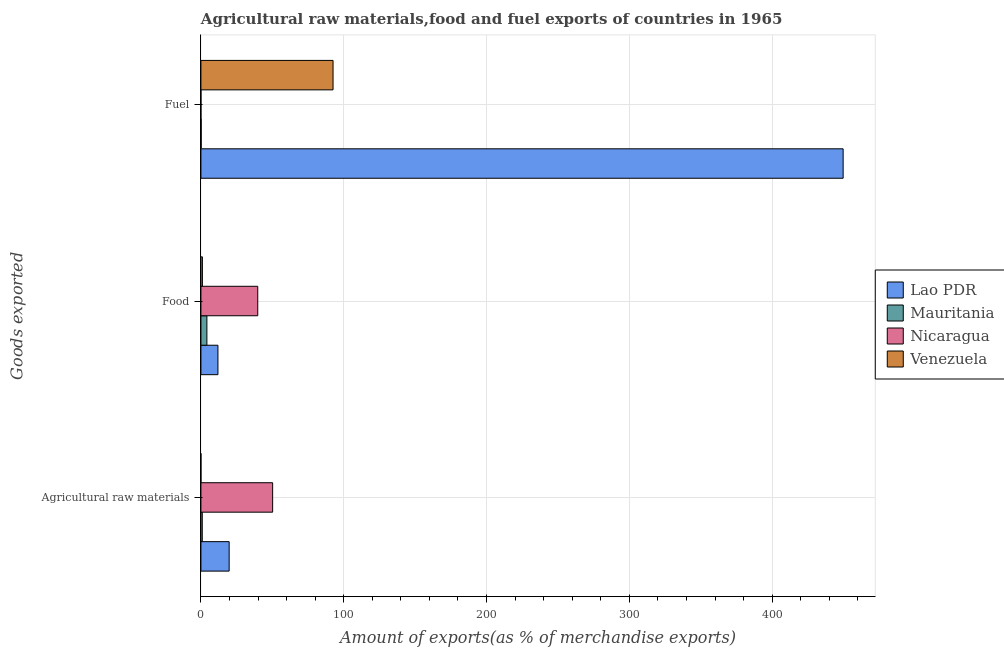How many different coloured bars are there?
Your answer should be very brief. 4. How many groups of bars are there?
Give a very brief answer. 3. Are the number of bars per tick equal to the number of legend labels?
Ensure brevity in your answer.  Yes. Are the number of bars on each tick of the Y-axis equal?
Ensure brevity in your answer.  Yes. How many bars are there on the 2nd tick from the top?
Ensure brevity in your answer.  4. What is the label of the 3rd group of bars from the top?
Provide a succinct answer. Agricultural raw materials. What is the percentage of raw materials exports in Venezuela?
Provide a succinct answer. 0.02. Across all countries, what is the maximum percentage of raw materials exports?
Make the answer very short. 50.22. Across all countries, what is the minimum percentage of food exports?
Offer a terse response. 1.05. In which country was the percentage of food exports maximum?
Provide a succinct answer. Nicaragua. In which country was the percentage of fuel exports minimum?
Provide a succinct answer. Nicaragua. What is the total percentage of fuel exports in the graph?
Give a very brief answer. 542.43. What is the difference between the percentage of raw materials exports in Mauritania and that in Lao PDR?
Make the answer very short. -18.83. What is the difference between the percentage of raw materials exports in Venezuela and the percentage of fuel exports in Mauritania?
Offer a very short reply. -0.17. What is the average percentage of fuel exports per country?
Provide a succinct answer. 135.61. What is the difference between the percentage of raw materials exports and percentage of food exports in Lao PDR?
Ensure brevity in your answer.  7.85. In how many countries, is the percentage of food exports greater than 60 %?
Ensure brevity in your answer.  0. What is the ratio of the percentage of raw materials exports in Venezuela to that in Mauritania?
Offer a very short reply. 0.02. Is the difference between the percentage of fuel exports in Venezuela and Lao PDR greater than the difference between the percentage of food exports in Venezuela and Lao PDR?
Your answer should be compact. No. What is the difference between the highest and the second highest percentage of food exports?
Offer a terse response. 27.88. What is the difference between the highest and the lowest percentage of fuel exports?
Make the answer very short. 449.71. In how many countries, is the percentage of raw materials exports greater than the average percentage of raw materials exports taken over all countries?
Your answer should be compact. 2. Is the sum of the percentage of food exports in Nicaragua and Mauritania greater than the maximum percentage of fuel exports across all countries?
Provide a succinct answer. No. What does the 4th bar from the top in Fuel represents?
Keep it short and to the point. Lao PDR. What does the 4th bar from the bottom in Food represents?
Make the answer very short. Venezuela. How many bars are there?
Keep it short and to the point. 12. Are all the bars in the graph horizontal?
Offer a terse response. Yes. How many countries are there in the graph?
Provide a short and direct response. 4. What is the difference between two consecutive major ticks on the X-axis?
Ensure brevity in your answer.  100. Where does the legend appear in the graph?
Your response must be concise. Center right. How many legend labels are there?
Offer a terse response. 4. What is the title of the graph?
Keep it short and to the point. Agricultural raw materials,food and fuel exports of countries in 1965. What is the label or title of the X-axis?
Ensure brevity in your answer.  Amount of exports(as % of merchandise exports). What is the label or title of the Y-axis?
Your answer should be compact. Goods exported. What is the Amount of exports(as % of merchandise exports) of Lao PDR in Agricultural raw materials?
Provide a short and direct response. 19.77. What is the Amount of exports(as % of merchandise exports) in Mauritania in Agricultural raw materials?
Ensure brevity in your answer.  0.94. What is the Amount of exports(as % of merchandise exports) of Nicaragua in Agricultural raw materials?
Offer a terse response. 50.22. What is the Amount of exports(as % of merchandise exports) in Venezuela in Agricultural raw materials?
Your answer should be very brief. 0.02. What is the Amount of exports(as % of merchandise exports) of Lao PDR in Food?
Provide a short and direct response. 11.92. What is the Amount of exports(as % of merchandise exports) in Mauritania in Food?
Keep it short and to the point. 4.18. What is the Amount of exports(as % of merchandise exports) of Nicaragua in Food?
Your answer should be compact. 39.8. What is the Amount of exports(as % of merchandise exports) of Venezuela in Food?
Make the answer very short. 1.05. What is the Amount of exports(as % of merchandise exports) of Lao PDR in Fuel?
Offer a very short reply. 449.72. What is the Amount of exports(as % of merchandise exports) in Mauritania in Fuel?
Give a very brief answer. 0.19. What is the Amount of exports(as % of merchandise exports) of Nicaragua in Fuel?
Provide a short and direct response. 0.01. What is the Amount of exports(as % of merchandise exports) in Venezuela in Fuel?
Your response must be concise. 92.52. Across all Goods exported, what is the maximum Amount of exports(as % of merchandise exports) in Lao PDR?
Keep it short and to the point. 449.72. Across all Goods exported, what is the maximum Amount of exports(as % of merchandise exports) of Mauritania?
Offer a terse response. 4.18. Across all Goods exported, what is the maximum Amount of exports(as % of merchandise exports) in Nicaragua?
Your response must be concise. 50.22. Across all Goods exported, what is the maximum Amount of exports(as % of merchandise exports) in Venezuela?
Provide a short and direct response. 92.52. Across all Goods exported, what is the minimum Amount of exports(as % of merchandise exports) of Lao PDR?
Ensure brevity in your answer.  11.92. Across all Goods exported, what is the minimum Amount of exports(as % of merchandise exports) in Mauritania?
Give a very brief answer. 0.19. Across all Goods exported, what is the minimum Amount of exports(as % of merchandise exports) of Nicaragua?
Give a very brief answer. 0.01. Across all Goods exported, what is the minimum Amount of exports(as % of merchandise exports) of Venezuela?
Provide a succinct answer. 0.02. What is the total Amount of exports(as % of merchandise exports) of Lao PDR in the graph?
Your answer should be very brief. 481.41. What is the total Amount of exports(as % of merchandise exports) in Mauritania in the graph?
Provide a short and direct response. 5.31. What is the total Amount of exports(as % of merchandise exports) of Nicaragua in the graph?
Your response must be concise. 90.02. What is the total Amount of exports(as % of merchandise exports) of Venezuela in the graph?
Provide a succinct answer. 93.59. What is the difference between the Amount of exports(as % of merchandise exports) in Lao PDR in Agricultural raw materials and that in Food?
Make the answer very short. 7.85. What is the difference between the Amount of exports(as % of merchandise exports) in Mauritania in Agricultural raw materials and that in Food?
Make the answer very short. -3.24. What is the difference between the Amount of exports(as % of merchandise exports) of Nicaragua in Agricultural raw materials and that in Food?
Ensure brevity in your answer.  10.42. What is the difference between the Amount of exports(as % of merchandise exports) in Venezuela in Agricultural raw materials and that in Food?
Provide a succinct answer. -1.03. What is the difference between the Amount of exports(as % of merchandise exports) of Lao PDR in Agricultural raw materials and that in Fuel?
Make the answer very short. -429.94. What is the difference between the Amount of exports(as % of merchandise exports) in Mauritania in Agricultural raw materials and that in Fuel?
Your answer should be compact. 0.75. What is the difference between the Amount of exports(as % of merchandise exports) in Nicaragua in Agricultural raw materials and that in Fuel?
Your answer should be compact. 50.21. What is the difference between the Amount of exports(as % of merchandise exports) of Venezuela in Agricultural raw materials and that in Fuel?
Provide a short and direct response. -92.5. What is the difference between the Amount of exports(as % of merchandise exports) in Lao PDR in Food and that in Fuel?
Provide a succinct answer. -437.79. What is the difference between the Amount of exports(as % of merchandise exports) in Mauritania in Food and that in Fuel?
Offer a very short reply. 4. What is the difference between the Amount of exports(as % of merchandise exports) in Nicaragua in Food and that in Fuel?
Offer a terse response. 39.79. What is the difference between the Amount of exports(as % of merchandise exports) of Venezuela in Food and that in Fuel?
Offer a terse response. -91.47. What is the difference between the Amount of exports(as % of merchandise exports) in Lao PDR in Agricultural raw materials and the Amount of exports(as % of merchandise exports) in Mauritania in Food?
Offer a very short reply. 15.59. What is the difference between the Amount of exports(as % of merchandise exports) of Lao PDR in Agricultural raw materials and the Amount of exports(as % of merchandise exports) of Nicaragua in Food?
Your answer should be compact. -20.03. What is the difference between the Amount of exports(as % of merchandise exports) in Lao PDR in Agricultural raw materials and the Amount of exports(as % of merchandise exports) in Venezuela in Food?
Offer a very short reply. 18.72. What is the difference between the Amount of exports(as % of merchandise exports) of Mauritania in Agricultural raw materials and the Amount of exports(as % of merchandise exports) of Nicaragua in Food?
Provide a short and direct response. -38.86. What is the difference between the Amount of exports(as % of merchandise exports) of Mauritania in Agricultural raw materials and the Amount of exports(as % of merchandise exports) of Venezuela in Food?
Keep it short and to the point. -0.11. What is the difference between the Amount of exports(as % of merchandise exports) in Nicaragua in Agricultural raw materials and the Amount of exports(as % of merchandise exports) in Venezuela in Food?
Your response must be concise. 49.17. What is the difference between the Amount of exports(as % of merchandise exports) in Lao PDR in Agricultural raw materials and the Amount of exports(as % of merchandise exports) in Mauritania in Fuel?
Make the answer very short. 19.59. What is the difference between the Amount of exports(as % of merchandise exports) in Lao PDR in Agricultural raw materials and the Amount of exports(as % of merchandise exports) in Nicaragua in Fuel?
Offer a very short reply. 19.76. What is the difference between the Amount of exports(as % of merchandise exports) in Lao PDR in Agricultural raw materials and the Amount of exports(as % of merchandise exports) in Venezuela in Fuel?
Keep it short and to the point. -72.75. What is the difference between the Amount of exports(as % of merchandise exports) of Mauritania in Agricultural raw materials and the Amount of exports(as % of merchandise exports) of Nicaragua in Fuel?
Make the answer very short. 0.93. What is the difference between the Amount of exports(as % of merchandise exports) of Mauritania in Agricultural raw materials and the Amount of exports(as % of merchandise exports) of Venezuela in Fuel?
Give a very brief answer. -91.58. What is the difference between the Amount of exports(as % of merchandise exports) of Nicaragua in Agricultural raw materials and the Amount of exports(as % of merchandise exports) of Venezuela in Fuel?
Make the answer very short. -42.3. What is the difference between the Amount of exports(as % of merchandise exports) of Lao PDR in Food and the Amount of exports(as % of merchandise exports) of Mauritania in Fuel?
Ensure brevity in your answer.  11.74. What is the difference between the Amount of exports(as % of merchandise exports) in Lao PDR in Food and the Amount of exports(as % of merchandise exports) in Nicaragua in Fuel?
Make the answer very short. 11.91. What is the difference between the Amount of exports(as % of merchandise exports) of Lao PDR in Food and the Amount of exports(as % of merchandise exports) of Venezuela in Fuel?
Offer a very short reply. -80.6. What is the difference between the Amount of exports(as % of merchandise exports) of Mauritania in Food and the Amount of exports(as % of merchandise exports) of Nicaragua in Fuel?
Your response must be concise. 4.18. What is the difference between the Amount of exports(as % of merchandise exports) in Mauritania in Food and the Amount of exports(as % of merchandise exports) in Venezuela in Fuel?
Ensure brevity in your answer.  -88.33. What is the difference between the Amount of exports(as % of merchandise exports) in Nicaragua in Food and the Amount of exports(as % of merchandise exports) in Venezuela in Fuel?
Ensure brevity in your answer.  -52.72. What is the average Amount of exports(as % of merchandise exports) in Lao PDR per Goods exported?
Provide a short and direct response. 160.47. What is the average Amount of exports(as % of merchandise exports) in Mauritania per Goods exported?
Your answer should be compact. 1.77. What is the average Amount of exports(as % of merchandise exports) of Nicaragua per Goods exported?
Keep it short and to the point. 30.01. What is the average Amount of exports(as % of merchandise exports) in Venezuela per Goods exported?
Give a very brief answer. 31.2. What is the difference between the Amount of exports(as % of merchandise exports) of Lao PDR and Amount of exports(as % of merchandise exports) of Mauritania in Agricultural raw materials?
Your response must be concise. 18.83. What is the difference between the Amount of exports(as % of merchandise exports) of Lao PDR and Amount of exports(as % of merchandise exports) of Nicaragua in Agricultural raw materials?
Ensure brevity in your answer.  -30.45. What is the difference between the Amount of exports(as % of merchandise exports) in Lao PDR and Amount of exports(as % of merchandise exports) in Venezuela in Agricultural raw materials?
Your answer should be very brief. 19.75. What is the difference between the Amount of exports(as % of merchandise exports) of Mauritania and Amount of exports(as % of merchandise exports) of Nicaragua in Agricultural raw materials?
Provide a succinct answer. -49.28. What is the difference between the Amount of exports(as % of merchandise exports) of Mauritania and Amount of exports(as % of merchandise exports) of Venezuela in Agricultural raw materials?
Your response must be concise. 0.92. What is the difference between the Amount of exports(as % of merchandise exports) in Nicaragua and Amount of exports(as % of merchandise exports) in Venezuela in Agricultural raw materials?
Provide a succinct answer. 50.2. What is the difference between the Amount of exports(as % of merchandise exports) in Lao PDR and Amount of exports(as % of merchandise exports) in Mauritania in Food?
Provide a short and direct response. 7.74. What is the difference between the Amount of exports(as % of merchandise exports) of Lao PDR and Amount of exports(as % of merchandise exports) of Nicaragua in Food?
Give a very brief answer. -27.88. What is the difference between the Amount of exports(as % of merchandise exports) in Lao PDR and Amount of exports(as % of merchandise exports) in Venezuela in Food?
Make the answer very short. 10.87. What is the difference between the Amount of exports(as % of merchandise exports) in Mauritania and Amount of exports(as % of merchandise exports) in Nicaragua in Food?
Give a very brief answer. -35.61. What is the difference between the Amount of exports(as % of merchandise exports) in Mauritania and Amount of exports(as % of merchandise exports) in Venezuela in Food?
Offer a terse response. 3.14. What is the difference between the Amount of exports(as % of merchandise exports) in Nicaragua and Amount of exports(as % of merchandise exports) in Venezuela in Food?
Make the answer very short. 38.75. What is the difference between the Amount of exports(as % of merchandise exports) in Lao PDR and Amount of exports(as % of merchandise exports) in Mauritania in Fuel?
Provide a succinct answer. 449.53. What is the difference between the Amount of exports(as % of merchandise exports) of Lao PDR and Amount of exports(as % of merchandise exports) of Nicaragua in Fuel?
Your answer should be very brief. 449.71. What is the difference between the Amount of exports(as % of merchandise exports) of Lao PDR and Amount of exports(as % of merchandise exports) of Venezuela in Fuel?
Offer a terse response. 357.2. What is the difference between the Amount of exports(as % of merchandise exports) in Mauritania and Amount of exports(as % of merchandise exports) in Nicaragua in Fuel?
Provide a short and direct response. 0.18. What is the difference between the Amount of exports(as % of merchandise exports) of Mauritania and Amount of exports(as % of merchandise exports) of Venezuela in Fuel?
Provide a short and direct response. -92.33. What is the difference between the Amount of exports(as % of merchandise exports) in Nicaragua and Amount of exports(as % of merchandise exports) in Venezuela in Fuel?
Your answer should be very brief. -92.51. What is the ratio of the Amount of exports(as % of merchandise exports) of Lao PDR in Agricultural raw materials to that in Food?
Your answer should be compact. 1.66. What is the ratio of the Amount of exports(as % of merchandise exports) in Mauritania in Agricultural raw materials to that in Food?
Your answer should be compact. 0.22. What is the ratio of the Amount of exports(as % of merchandise exports) of Nicaragua in Agricultural raw materials to that in Food?
Your response must be concise. 1.26. What is the ratio of the Amount of exports(as % of merchandise exports) of Venezuela in Agricultural raw materials to that in Food?
Give a very brief answer. 0.02. What is the ratio of the Amount of exports(as % of merchandise exports) of Lao PDR in Agricultural raw materials to that in Fuel?
Give a very brief answer. 0.04. What is the ratio of the Amount of exports(as % of merchandise exports) in Mauritania in Agricultural raw materials to that in Fuel?
Keep it short and to the point. 5.08. What is the ratio of the Amount of exports(as % of merchandise exports) of Nicaragua in Agricultural raw materials to that in Fuel?
Your answer should be compact. 5958.69. What is the ratio of the Amount of exports(as % of merchandise exports) in Venezuela in Agricultural raw materials to that in Fuel?
Ensure brevity in your answer.  0. What is the ratio of the Amount of exports(as % of merchandise exports) in Lao PDR in Food to that in Fuel?
Ensure brevity in your answer.  0.03. What is the ratio of the Amount of exports(as % of merchandise exports) in Mauritania in Food to that in Fuel?
Your answer should be very brief. 22.6. What is the ratio of the Amount of exports(as % of merchandise exports) of Nicaragua in Food to that in Fuel?
Your answer should be compact. 4722.01. What is the ratio of the Amount of exports(as % of merchandise exports) of Venezuela in Food to that in Fuel?
Your answer should be compact. 0.01. What is the difference between the highest and the second highest Amount of exports(as % of merchandise exports) in Lao PDR?
Your response must be concise. 429.94. What is the difference between the highest and the second highest Amount of exports(as % of merchandise exports) in Mauritania?
Provide a short and direct response. 3.24. What is the difference between the highest and the second highest Amount of exports(as % of merchandise exports) of Nicaragua?
Ensure brevity in your answer.  10.42. What is the difference between the highest and the second highest Amount of exports(as % of merchandise exports) in Venezuela?
Your answer should be very brief. 91.47. What is the difference between the highest and the lowest Amount of exports(as % of merchandise exports) of Lao PDR?
Make the answer very short. 437.79. What is the difference between the highest and the lowest Amount of exports(as % of merchandise exports) in Mauritania?
Provide a short and direct response. 4. What is the difference between the highest and the lowest Amount of exports(as % of merchandise exports) in Nicaragua?
Offer a terse response. 50.21. What is the difference between the highest and the lowest Amount of exports(as % of merchandise exports) in Venezuela?
Your answer should be compact. 92.5. 